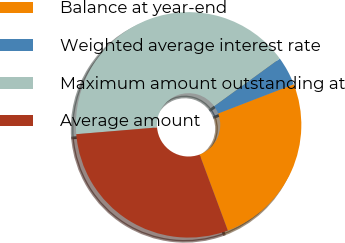<chart> <loc_0><loc_0><loc_500><loc_500><pie_chart><fcel>Balance at year-end<fcel>Weighted average interest rate<fcel>Maximum amount outstanding at<fcel>Average amount<nl><fcel>25.21%<fcel>4.14%<fcel>41.32%<fcel>29.34%<nl></chart> 